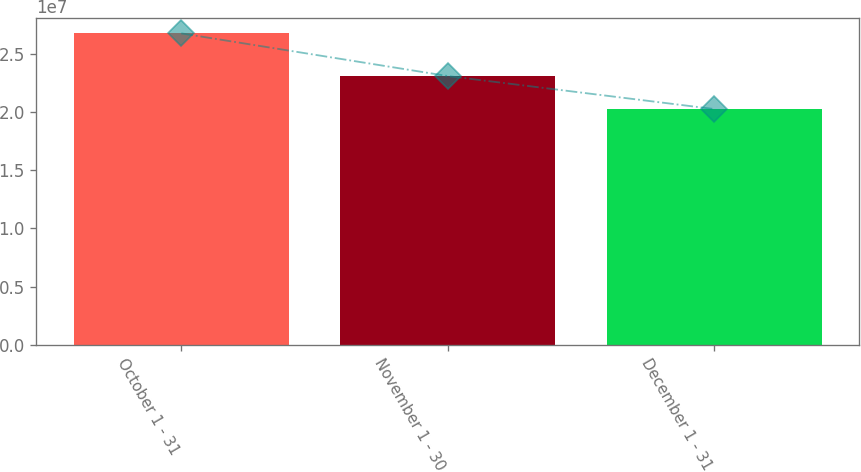<chart> <loc_0><loc_0><loc_500><loc_500><bar_chart><fcel>October 1 - 31<fcel>November 1 - 30<fcel>December 1 - 31<nl><fcel>2.67506e+07<fcel>2.30824e+07<fcel>2.02465e+07<nl></chart> 